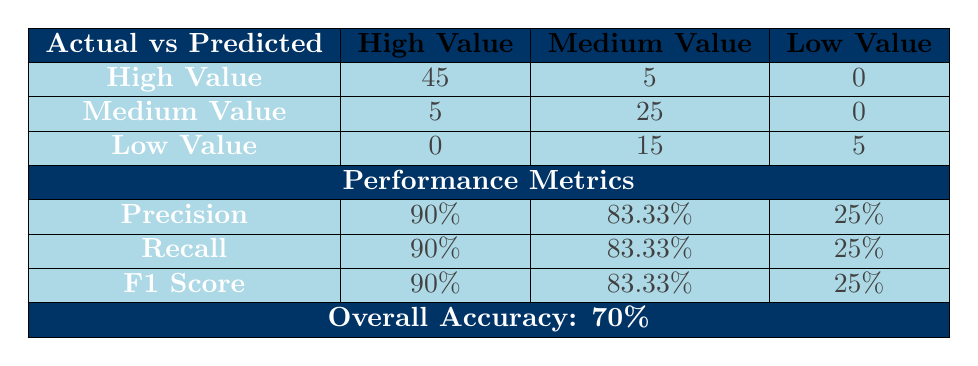What is the Overall Accuracy of the model? The table explicitly states the Overall Accuracy as 70%.
Answer: 70% How many True Positives were there for Low Value customers? The table shows that the True Positives for Low Value customers is 0.
Answer: 0 What is the Precision for Medium Value customers? According to the table, the Precision for Medium Value customers is 83.33%.
Answer: 83.33% What is the total number of customers classified as High Value? To find this, we look at the actual High Value column, which has 50 customers.
Answer: 50 What is the difference in Recall between High Value and Low Value segments? The Recall for High Value is 90%, while for Low Value it is 25%. The difference is 90 - 25 = 65.
Answer: 65 Is the model more effective at identifying High Value or Low Value customers? The Precision for High Value customers is 90%, and for Low Value customers, it is 25%. Since 90% is greater than 25%, the model is more effective at identifying High Value customers.
Answer: Yes What percentage of Medium Value customers were incorrectly classified as High Value? There were 5 False Positives for Medium Value customers out of 30 actual Medium Value customers. The percentage is (5/30) * 100 = 16.67%.
Answer: 16.67% How many total False Negatives are there across all customer segments? The total False Negatives can be found by adding those for High Value (5) and Low Value (15), which gives us 5 + 15 = 20.
Answer: 20 What is the F1 Score for Low Value customers? The table shows that the F1 Score for Low Value customers is 25%.
Answer: 25% What is the total number of customers who were classified as Medium Value? Looking at the predicted Medium Value row, we find that 5 (False Negatives) + 25 (True Negatives) = 30 customers were classified as Medium Value.
Answer: 30 